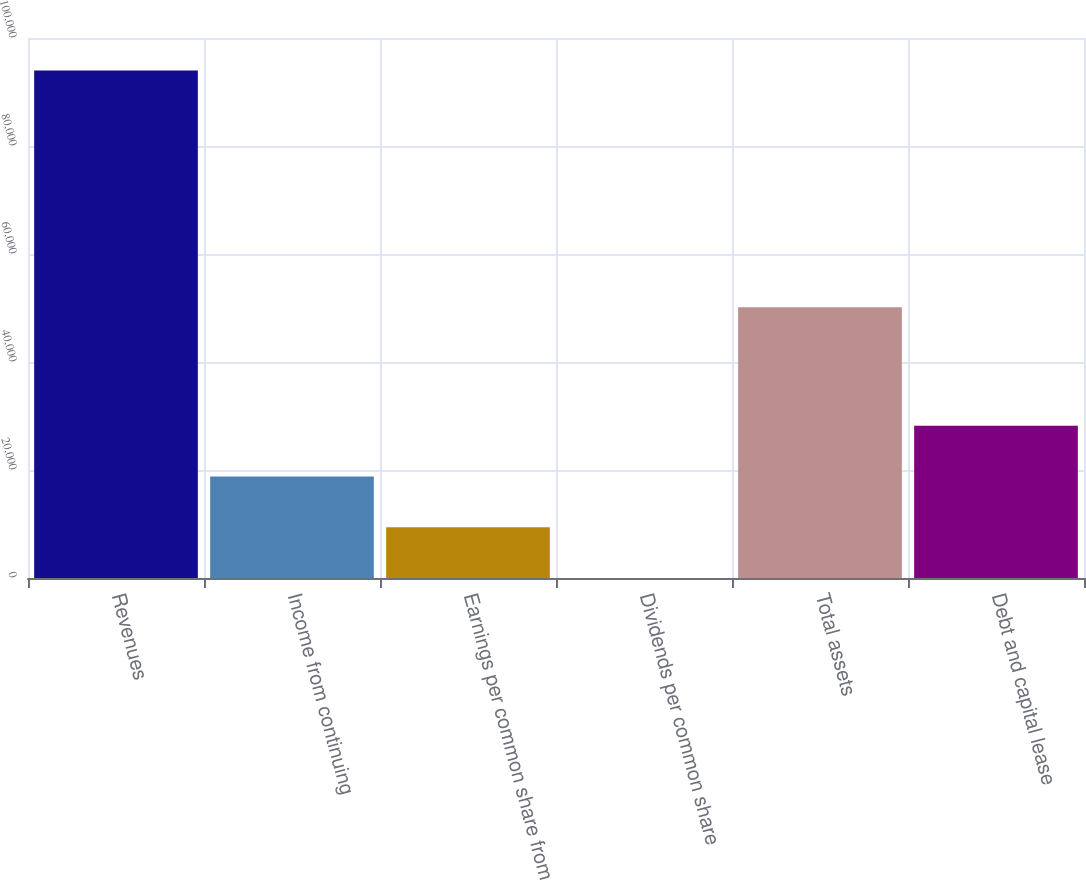Convert chart. <chart><loc_0><loc_0><loc_500><loc_500><bar_chart><fcel>Revenues<fcel>Income from continuing<fcel>Earnings per common share from<fcel>Dividends per common share<fcel>Total assets<fcel>Debt and capital lease<nl><fcel>93980<fcel>18798.2<fcel>9400.52<fcel>2.8<fcel>50158<fcel>28196<nl></chart> 